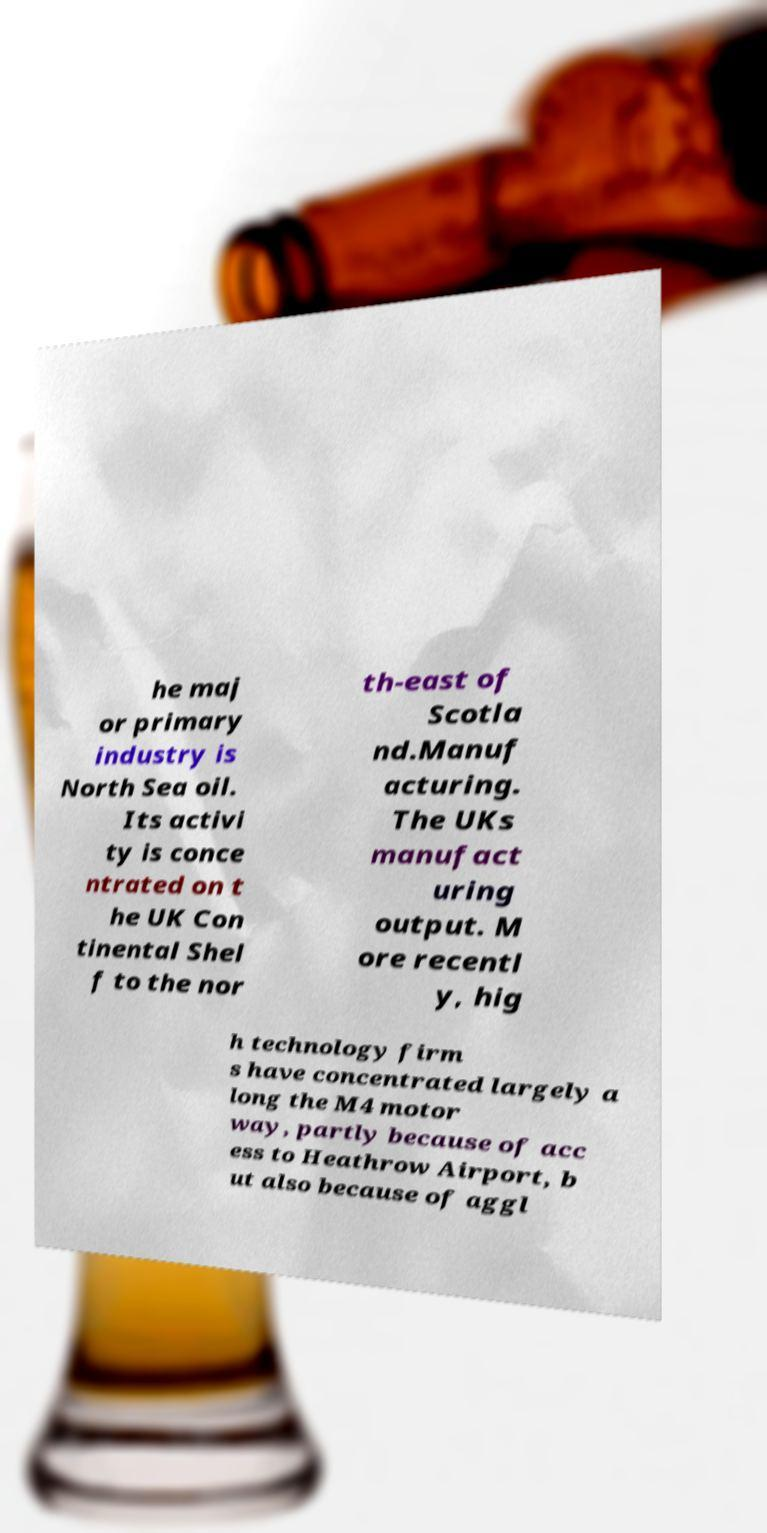Please identify and transcribe the text found in this image. he maj or primary industry is North Sea oil. Its activi ty is conce ntrated on t he UK Con tinental Shel f to the nor th-east of Scotla nd.Manuf acturing. The UKs manufact uring output. M ore recentl y, hig h technology firm s have concentrated largely a long the M4 motor way, partly because of acc ess to Heathrow Airport, b ut also because of aggl 